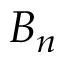Convert formula to latex. <formula><loc_0><loc_0><loc_500><loc_500>B _ { n }</formula> 